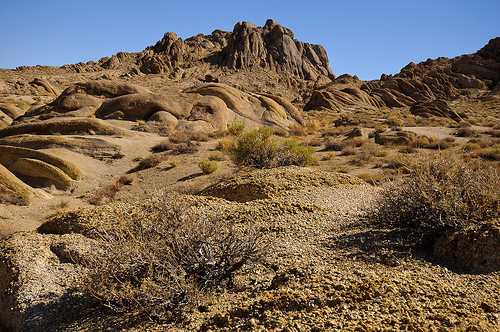<image>
Is the desert under the mountain? No. The desert is not positioned under the mountain. The vertical relationship between these objects is different. 